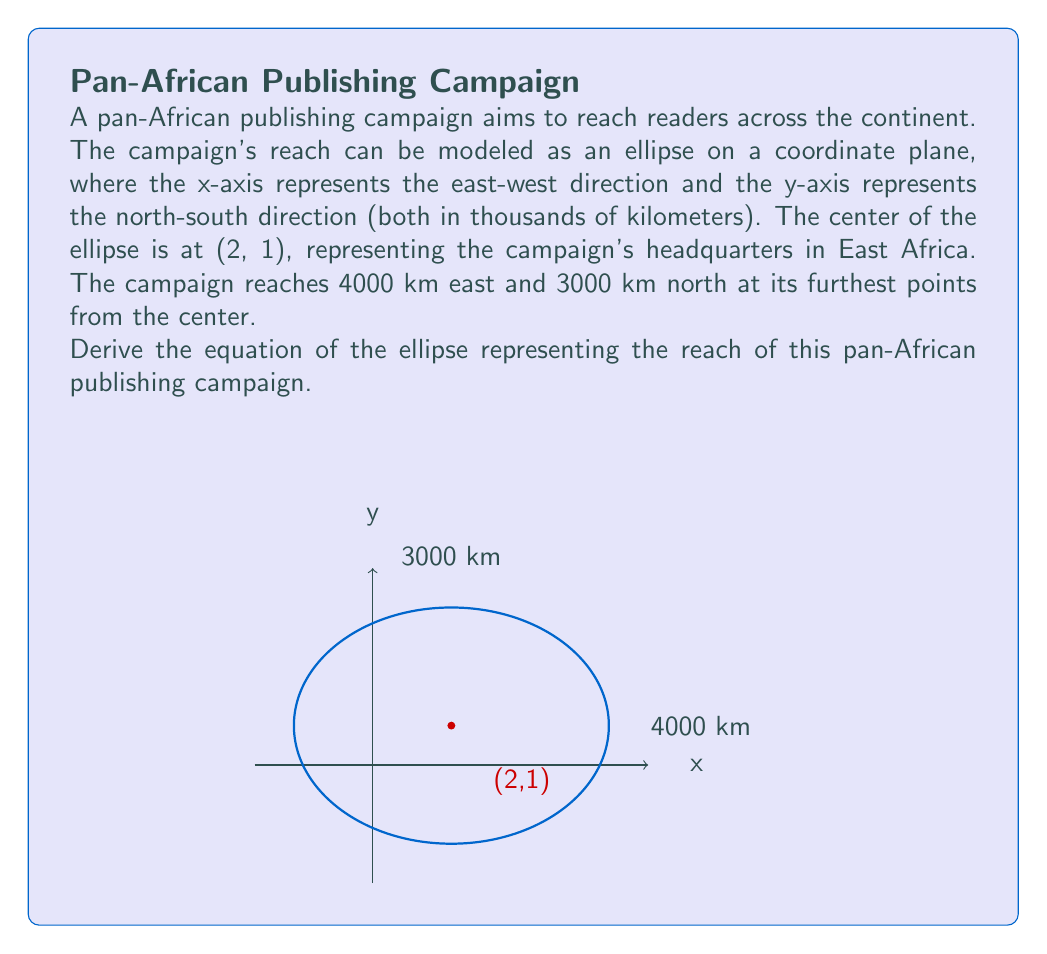Can you answer this question? Let's approach this step-by-step:

1) The standard form of an ellipse equation is:

   $$\frac{(x-h)^2}{a^2} + \frac{(y-k)^2}{b^2} = 1$$

   where (h,k) is the center, and a and b are the lengths of the semi-major and semi-minor axes.

2) We're given that the center is at (2,1), so h = 2 and k = 1.

3) The ellipse reaches 4000 km east and 3000 km north from the center. These are the full lengths of the axes, so we need to halve them to get the semi-axes:
   a = 4000/2 = 2000 km
   b = 3000/2 = 1500 km

4) Now, let's substitute these values into our equation:

   $$\frac{(x-2)^2}{2000^2} + \frac{(y-1)^2}{1500^2} = 1$$

5) Simplify by squaring the denominators:

   $$\frac{(x-2)^2}{4,000,000} + \frac{(y-1)^2}{2,250,000} = 1$$

6) To make the equation more readable, we can multiply both sides by 4,000,000:

   $$(x-2)^2 + \frac{16}{9}(y-1)^2 = 4,000,000$$

This is the final equation of the ellipse representing the reach of the pan-African publishing campaign.
Answer: $$(x-2)^2 + \frac{16}{9}(y-1)^2 = 4,000,000$$ 